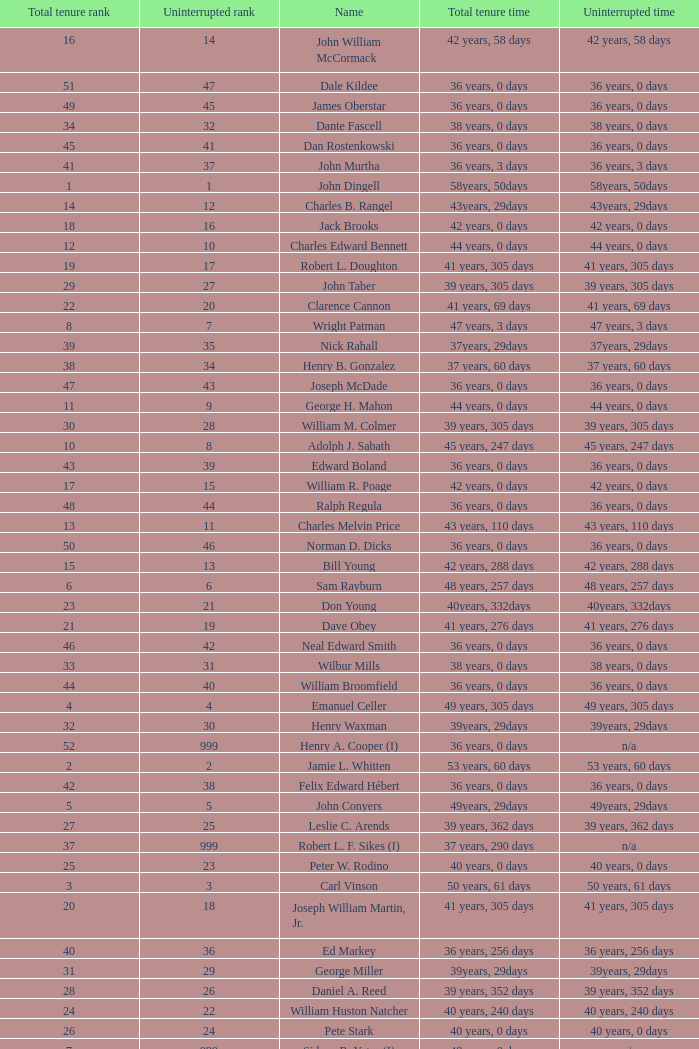How many uninterrupted ranks does john dingell have? 1.0. Could you parse the entire table as a dict? {'header': ['Total tenure rank', 'Uninterrupted rank', 'Name', 'Total tenure time', 'Uninterrupted time'], 'rows': [['16', '14', 'John William McCormack', '42 years, 58 days', '42 years, 58 days'], ['51', '47', 'Dale Kildee', '36 years, 0 days', '36 years, 0 days'], ['49', '45', 'James Oberstar', '36 years, 0 days', '36 years, 0 days'], ['34', '32', 'Dante Fascell', '38 years, 0 days', '38 years, 0 days'], ['45', '41', 'Dan Rostenkowski', '36 years, 0 days', '36 years, 0 days'], ['41', '37', 'John Murtha', '36 years, 3 days', '36 years, 3 days'], ['1', '1', 'John Dingell', '58years, 50days', '58years, 50days'], ['14', '12', 'Charles B. Rangel', '43years, 29days', '43years, 29days'], ['18', '16', 'Jack Brooks', '42 years, 0 days', '42 years, 0 days'], ['12', '10', 'Charles Edward Bennett', '44 years, 0 days', '44 years, 0 days'], ['19', '17', 'Robert L. Doughton', '41 years, 305 days', '41 years, 305 days'], ['29', '27', 'John Taber', '39 years, 305 days', '39 years, 305 days'], ['22', '20', 'Clarence Cannon', '41 years, 69 days', '41 years, 69 days'], ['8', '7', 'Wright Patman', '47 years, 3 days', '47 years, 3 days'], ['39', '35', 'Nick Rahall', '37years, 29days', '37years, 29days'], ['38', '34', 'Henry B. Gonzalez', '37 years, 60 days', '37 years, 60 days'], ['47', '43', 'Joseph McDade', '36 years, 0 days', '36 years, 0 days'], ['11', '9', 'George H. Mahon', '44 years, 0 days', '44 years, 0 days'], ['30', '28', 'William M. Colmer', '39 years, 305 days', '39 years, 305 days'], ['10', '8', 'Adolph J. Sabath', '45 years, 247 days', '45 years, 247 days'], ['43', '39', 'Edward Boland', '36 years, 0 days', '36 years, 0 days'], ['17', '15', 'William R. Poage', '42 years, 0 days', '42 years, 0 days'], ['48', '44', 'Ralph Regula', '36 years, 0 days', '36 years, 0 days'], ['13', '11', 'Charles Melvin Price', '43 years, 110 days', '43 years, 110 days'], ['50', '46', 'Norman D. Dicks', '36 years, 0 days', '36 years, 0 days'], ['15', '13', 'Bill Young', '42 years, 288 days', '42 years, 288 days'], ['6', '6', 'Sam Rayburn', '48 years, 257 days', '48 years, 257 days'], ['23', '21', 'Don Young', '40years, 332days', '40years, 332days'], ['21', '19', 'Dave Obey', '41 years, 276 days', '41 years, 276 days'], ['46', '42', 'Neal Edward Smith', '36 years, 0 days', '36 years, 0 days'], ['33', '31', 'Wilbur Mills', '38 years, 0 days', '38 years, 0 days'], ['44', '40', 'William Broomfield', '36 years, 0 days', '36 years, 0 days'], ['4', '4', 'Emanuel Celler', '49 years, 305 days', '49 years, 305 days'], ['32', '30', 'Henry Waxman', '39years, 29days', '39years, 29days'], ['52', '999', 'Henry A. Cooper (I)', '36 years, 0 days', 'n/a'], ['2', '2', 'Jamie L. Whitten', '53 years, 60 days', '53 years, 60 days'], ['42', '38', 'Felix Edward Hébert', '36 years, 0 days', '36 years, 0 days'], ['5', '5', 'John Conyers', '49years, 29days', '49years, 29days'], ['27', '25', 'Leslie C. Arends', '39 years, 362 days', '39 years, 362 days'], ['37', '999', 'Robert L. F. Sikes (I)', '37 years, 290 days', 'n/a'], ['25', '23', 'Peter W. Rodino', '40 years, 0 days', '40 years, 0 days'], ['3', '3', 'Carl Vinson', '50 years, 61 days', '50 years, 61 days'], ['20', '18', 'Joseph William Martin, Jr.', '41 years, 305 days', '41 years, 305 days'], ['40', '36', 'Ed Markey', '36 years, 256 days', '36 years, 256 days'], ['31', '29', 'George Miller', '39years, 29days', '39years, 29days'], ['28', '26', 'Daniel A. Reed', '39 years, 352 days', '39 years, 352 days'], ['24', '22', 'William Huston Natcher', '40 years, 240 days', '40 years, 240 days'], ['26', '24', 'Pete Stark', '40 years, 0 days', '40 years, 0 days'], ['7', '999', 'Sidney R. Yates (I)', '48 years, 0 days', 'n/a'], ['9', '999', 'Joseph Gurney Cannon (I)', '46 years, 0 days', 'n/a'], ['36', '999', 'Robert Crosser (I)', '37 years, 305 days', 'n/a'], ['35', '33', 'Robert H. Michel', '38 years, 0 days', '38 years, 0 days']]} 